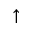Convert formula to latex. <formula><loc_0><loc_0><loc_500><loc_500>\uparrow</formula> 